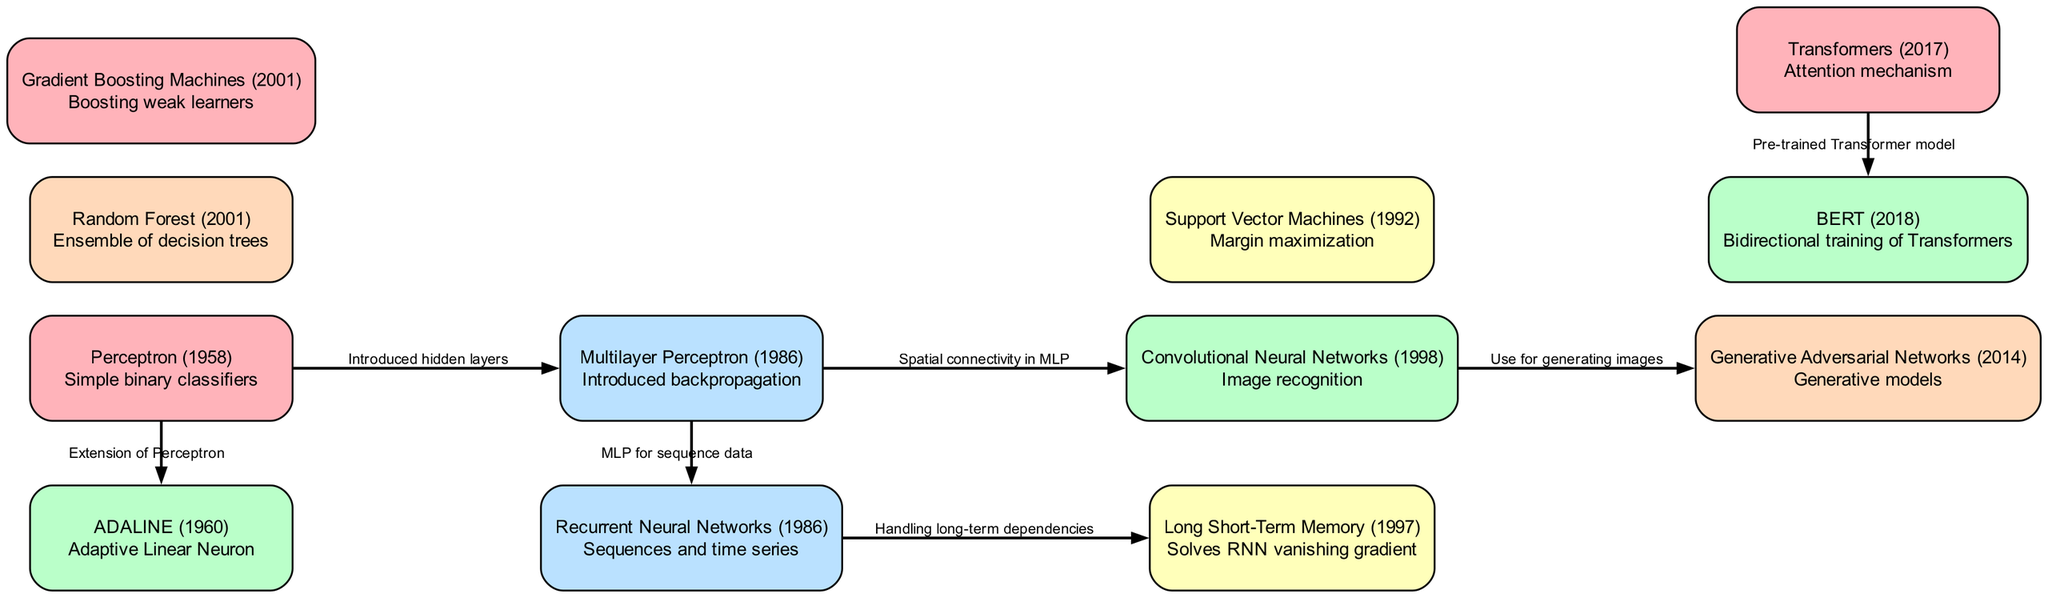What is the earliest machine learning algorithm in the diagram? The diagram presents a timeline of machine learning algorithms, starting with the Perceptron, labeled as "Perceptron (1958)". This indicates it is the first listed and therefore the earliest algorithm.
Answer: Perceptron (1958) How many algorithms are listed in the diagram? By counting each node in the diagram, we find a total of twelve distinct machine learning algorithms are represented in the structure, thus confirming the count.
Answer: 12 Which algorithm is indicated as using "Attention mechanism"? The node labeled "Transformers (2017)" explicitly states it utilizes an attention mechanism. Therefore, it is the algorithm associated with this specific description.
Answer: Transformers (2017) Which algorithm follows the "Multilayer Perceptron"? The diagram shows that the "Support Vector Machines (1992)" follows from the "Multilayer Perceptron (1986)", identifying the relationship clearly with a directed edge.
Answer: Support Vector Machines (1992) What connection is described between CNN and GAN? The edge connecting "CNN" to "GAN" indicates that CNN is used for generating images, showing a direct relationship that emphasizes CNN's generative aspect.
Answer: Use for generating images Which algorithm is the extension of the Perceptron? The edge from the "Perceptron" node to "ADALINE" states that ADALINE is an extension of the Perceptron, clarifying the evolutionary relationship.
Answer: ADALINE (1960) What solves the RNN vanishing gradient issue? The diagram indicates that "Long Short-Term Memory (1997)" handles the vanishing gradient issue found in RNNs, as shown by the directed edge connecting these two nodes.
Answer: Long Short-Term Memory (1997) How are BERT and Transformers related? The diagram clearly shows that "BERT (2018)" derives from "Transformers (2017)" through a directed edge that explains BERT is a pre-trained Transformer model, establishing a clear relationship.
Answer: Pre-trained Transformer model 